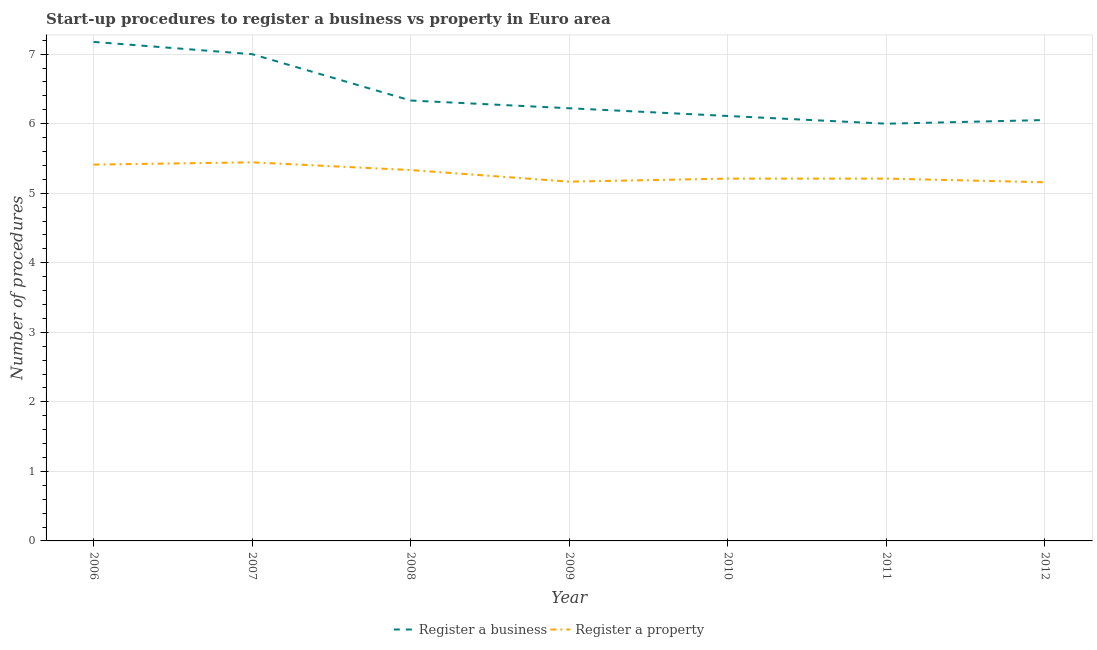Does the line corresponding to number of procedures to register a business intersect with the line corresponding to number of procedures to register a property?
Your response must be concise. No. What is the number of procedures to register a property in 2009?
Your answer should be very brief. 5.17. Across all years, what is the maximum number of procedures to register a business?
Offer a very short reply. 7.18. Across all years, what is the minimum number of procedures to register a property?
Provide a succinct answer. 5.16. What is the total number of procedures to register a property in the graph?
Offer a terse response. 36.94. What is the difference between the number of procedures to register a business in 2008 and that in 2010?
Ensure brevity in your answer.  0.22. What is the difference between the number of procedures to register a property in 2011 and the number of procedures to register a business in 2006?
Provide a short and direct response. -1.97. What is the average number of procedures to register a business per year?
Offer a terse response. 6.41. In the year 2009, what is the difference between the number of procedures to register a business and number of procedures to register a property?
Provide a succinct answer. 1.06. What is the ratio of the number of procedures to register a business in 2010 to that in 2012?
Offer a very short reply. 1.01. What is the difference between the highest and the second highest number of procedures to register a business?
Your answer should be very brief. 0.18. What is the difference between the highest and the lowest number of procedures to register a business?
Give a very brief answer. 1.18. Is the number of procedures to register a property strictly less than the number of procedures to register a business over the years?
Keep it short and to the point. Yes. How many years are there in the graph?
Make the answer very short. 7. Are the values on the major ticks of Y-axis written in scientific E-notation?
Keep it short and to the point. No. Where does the legend appear in the graph?
Make the answer very short. Bottom center. How many legend labels are there?
Provide a succinct answer. 2. How are the legend labels stacked?
Your answer should be compact. Horizontal. What is the title of the graph?
Provide a succinct answer. Start-up procedures to register a business vs property in Euro area. What is the label or title of the Y-axis?
Your response must be concise. Number of procedures. What is the Number of procedures of Register a business in 2006?
Provide a succinct answer. 7.18. What is the Number of procedures of Register a property in 2006?
Your answer should be compact. 5.41. What is the Number of procedures in Register a property in 2007?
Your response must be concise. 5.44. What is the Number of procedures of Register a business in 2008?
Offer a terse response. 6.33. What is the Number of procedures of Register a property in 2008?
Offer a very short reply. 5.33. What is the Number of procedures in Register a business in 2009?
Ensure brevity in your answer.  6.22. What is the Number of procedures of Register a property in 2009?
Your answer should be compact. 5.17. What is the Number of procedures of Register a business in 2010?
Offer a very short reply. 6.11. What is the Number of procedures of Register a property in 2010?
Provide a succinct answer. 5.21. What is the Number of procedures in Register a business in 2011?
Give a very brief answer. 6. What is the Number of procedures of Register a property in 2011?
Your answer should be compact. 5.21. What is the Number of procedures in Register a business in 2012?
Provide a succinct answer. 6.05. What is the Number of procedures of Register a property in 2012?
Provide a short and direct response. 5.16. Across all years, what is the maximum Number of procedures of Register a business?
Your answer should be very brief. 7.18. Across all years, what is the maximum Number of procedures of Register a property?
Offer a terse response. 5.44. Across all years, what is the minimum Number of procedures of Register a property?
Offer a very short reply. 5.16. What is the total Number of procedures in Register a business in the graph?
Your answer should be compact. 44.9. What is the total Number of procedures in Register a property in the graph?
Give a very brief answer. 36.94. What is the difference between the Number of procedures of Register a business in 2006 and that in 2007?
Ensure brevity in your answer.  0.18. What is the difference between the Number of procedures in Register a property in 2006 and that in 2007?
Your answer should be very brief. -0.03. What is the difference between the Number of procedures in Register a business in 2006 and that in 2008?
Ensure brevity in your answer.  0.84. What is the difference between the Number of procedures in Register a property in 2006 and that in 2008?
Your answer should be very brief. 0.08. What is the difference between the Number of procedures in Register a business in 2006 and that in 2009?
Provide a succinct answer. 0.95. What is the difference between the Number of procedures in Register a property in 2006 and that in 2009?
Provide a short and direct response. 0.25. What is the difference between the Number of procedures in Register a business in 2006 and that in 2010?
Give a very brief answer. 1.07. What is the difference between the Number of procedures in Register a property in 2006 and that in 2010?
Ensure brevity in your answer.  0.2. What is the difference between the Number of procedures in Register a business in 2006 and that in 2011?
Ensure brevity in your answer.  1.18. What is the difference between the Number of procedures in Register a property in 2006 and that in 2011?
Provide a succinct answer. 0.2. What is the difference between the Number of procedures in Register a business in 2006 and that in 2012?
Your answer should be compact. 1.12. What is the difference between the Number of procedures of Register a property in 2006 and that in 2012?
Ensure brevity in your answer.  0.25. What is the difference between the Number of procedures in Register a business in 2007 and that in 2009?
Make the answer very short. 0.78. What is the difference between the Number of procedures in Register a property in 2007 and that in 2009?
Your answer should be compact. 0.28. What is the difference between the Number of procedures of Register a property in 2007 and that in 2010?
Ensure brevity in your answer.  0.23. What is the difference between the Number of procedures in Register a property in 2007 and that in 2011?
Provide a succinct answer. 0.23. What is the difference between the Number of procedures of Register a business in 2007 and that in 2012?
Make the answer very short. 0.95. What is the difference between the Number of procedures of Register a property in 2007 and that in 2012?
Ensure brevity in your answer.  0.29. What is the difference between the Number of procedures in Register a business in 2008 and that in 2009?
Keep it short and to the point. 0.11. What is the difference between the Number of procedures in Register a property in 2008 and that in 2009?
Your answer should be very brief. 0.17. What is the difference between the Number of procedures in Register a business in 2008 and that in 2010?
Your answer should be compact. 0.22. What is the difference between the Number of procedures of Register a property in 2008 and that in 2010?
Your answer should be very brief. 0.12. What is the difference between the Number of procedures in Register a business in 2008 and that in 2011?
Give a very brief answer. 0.33. What is the difference between the Number of procedures in Register a property in 2008 and that in 2011?
Make the answer very short. 0.12. What is the difference between the Number of procedures of Register a business in 2008 and that in 2012?
Your answer should be very brief. 0.28. What is the difference between the Number of procedures of Register a property in 2008 and that in 2012?
Your answer should be very brief. 0.18. What is the difference between the Number of procedures in Register a business in 2009 and that in 2010?
Your response must be concise. 0.11. What is the difference between the Number of procedures in Register a property in 2009 and that in 2010?
Ensure brevity in your answer.  -0.04. What is the difference between the Number of procedures of Register a business in 2009 and that in 2011?
Make the answer very short. 0.22. What is the difference between the Number of procedures of Register a property in 2009 and that in 2011?
Your answer should be compact. -0.04. What is the difference between the Number of procedures in Register a business in 2009 and that in 2012?
Keep it short and to the point. 0.17. What is the difference between the Number of procedures of Register a property in 2009 and that in 2012?
Make the answer very short. 0.01. What is the difference between the Number of procedures in Register a business in 2010 and that in 2011?
Ensure brevity in your answer.  0.11. What is the difference between the Number of procedures in Register a business in 2010 and that in 2012?
Keep it short and to the point. 0.06. What is the difference between the Number of procedures in Register a property in 2010 and that in 2012?
Your response must be concise. 0.05. What is the difference between the Number of procedures of Register a business in 2011 and that in 2012?
Your response must be concise. -0.05. What is the difference between the Number of procedures in Register a property in 2011 and that in 2012?
Provide a succinct answer. 0.05. What is the difference between the Number of procedures of Register a business in 2006 and the Number of procedures of Register a property in 2007?
Provide a short and direct response. 1.73. What is the difference between the Number of procedures of Register a business in 2006 and the Number of procedures of Register a property in 2008?
Your answer should be very brief. 1.84. What is the difference between the Number of procedures of Register a business in 2006 and the Number of procedures of Register a property in 2009?
Ensure brevity in your answer.  2.01. What is the difference between the Number of procedures in Register a business in 2006 and the Number of procedures in Register a property in 2010?
Offer a very short reply. 1.97. What is the difference between the Number of procedures in Register a business in 2006 and the Number of procedures in Register a property in 2011?
Make the answer very short. 1.97. What is the difference between the Number of procedures of Register a business in 2006 and the Number of procedures of Register a property in 2012?
Provide a succinct answer. 2.02. What is the difference between the Number of procedures of Register a business in 2007 and the Number of procedures of Register a property in 2008?
Offer a very short reply. 1.67. What is the difference between the Number of procedures in Register a business in 2007 and the Number of procedures in Register a property in 2009?
Make the answer very short. 1.83. What is the difference between the Number of procedures in Register a business in 2007 and the Number of procedures in Register a property in 2010?
Keep it short and to the point. 1.79. What is the difference between the Number of procedures of Register a business in 2007 and the Number of procedures of Register a property in 2011?
Your answer should be very brief. 1.79. What is the difference between the Number of procedures of Register a business in 2007 and the Number of procedures of Register a property in 2012?
Keep it short and to the point. 1.84. What is the difference between the Number of procedures in Register a business in 2008 and the Number of procedures in Register a property in 2010?
Your answer should be compact. 1.12. What is the difference between the Number of procedures of Register a business in 2008 and the Number of procedures of Register a property in 2011?
Make the answer very short. 1.12. What is the difference between the Number of procedures in Register a business in 2008 and the Number of procedures in Register a property in 2012?
Give a very brief answer. 1.18. What is the difference between the Number of procedures in Register a business in 2009 and the Number of procedures in Register a property in 2010?
Your answer should be compact. 1.01. What is the difference between the Number of procedures in Register a business in 2009 and the Number of procedures in Register a property in 2011?
Your answer should be very brief. 1.01. What is the difference between the Number of procedures of Register a business in 2009 and the Number of procedures of Register a property in 2012?
Offer a very short reply. 1.06. What is the difference between the Number of procedures in Register a business in 2010 and the Number of procedures in Register a property in 2011?
Offer a terse response. 0.9. What is the difference between the Number of procedures of Register a business in 2010 and the Number of procedures of Register a property in 2012?
Provide a succinct answer. 0.95. What is the difference between the Number of procedures in Register a business in 2011 and the Number of procedures in Register a property in 2012?
Give a very brief answer. 0.84. What is the average Number of procedures of Register a business per year?
Your answer should be compact. 6.41. What is the average Number of procedures of Register a property per year?
Offer a very short reply. 5.28. In the year 2006, what is the difference between the Number of procedures in Register a business and Number of procedures in Register a property?
Offer a terse response. 1.76. In the year 2007, what is the difference between the Number of procedures in Register a business and Number of procedures in Register a property?
Make the answer very short. 1.56. In the year 2009, what is the difference between the Number of procedures of Register a business and Number of procedures of Register a property?
Provide a short and direct response. 1.06. In the year 2010, what is the difference between the Number of procedures of Register a business and Number of procedures of Register a property?
Ensure brevity in your answer.  0.9. In the year 2011, what is the difference between the Number of procedures of Register a business and Number of procedures of Register a property?
Provide a short and direct response. 0.79. In the year 2012, what is the difference between the Number of procedures in Register a business and Number of procedures in Register a property?
Provide a short and direct response. 0.89. What is the ratio of the Number of procedures in Register a business in 2006 to that in 2007?
Your response must be concise. 1.03. What is the ratio of the Number of procedures in Register a business in 2006 to that in 2008?
Your response must be concise. 1.13. What is the ratio of the Number of procedures of Register a property in 2006 to that in 2008?
Ensure brevity in your answer.  1.01. What is the ratio of the Number of procedures in Register a business in 2006 to that in 2009?
Your answer should be compact. 1.15. What is the ratio of the Number of procedures in Register a property in 2006 to that in 2009?
Keep it short and to the point. 1.05. What is the ratio of the Number of procedures of Register a business in 2006 to that in 2010?
Offer a very short reply. 1.17. What is the ratio of the Number of procedures in Register a property in 2006 to that in 2010?
Make the answer very short. 1.04. What is the ratio of the Number of procedures in Register a business in 2006 to that in 2011?
Your answer should be very brief. 1.2. What is the ratio of the Number of procedures of Register a property in 2006 to that in 2011?
Offer a terse response. 1.04. What is the ratio of the Number of procedures in Register a business in 2006 to that in 2012?
Provide a short and direct response. 1.19. What is the ratio of the Number of procedures of Register a property in 2006 to that in 2012?
Offer a very short reply. 1.05. What is the ratio of the Number of procedures of Register a business in 2007 to that in 2008?
Your answer should be very brief. 1.11. What is the ratio of the Number of procedures of Register a property in 2007 to that in 2008?
Provide a succinct answer. 1.02. What is the ratio of the Number of procedures of Register a property in 2007 to that in 2009?
Keep it short and to the point. 1.05. What is the ratio of the Number of procedures in Register a business in 2007 to that in 2010?
Give a very brief answer. 1.15. What is the ratio of the Number of procedures of Register a property in 2007 to that in 2010?
Your response must be concise. 1.04. What is the ratio of the Number of procedures of Register a business in 2007 to that in 2011?
Your response must be concise. 1.17. What is the ratio of the Number of procedures in Register a property in 2007 to that in 2011?
Make the answer very short. 1.04. What is the ratio of the Number of procedures in Register a business in 2007 to that in 2012?
Your answer should be very brief. 1.16. What is the ratio of the Number of procedures in Register a property in 2007 to that in 2012?
Offer a terse response. 1.06. What is the ratio of the Number of procedures in Register a business in 2008 to that in 2009?
Your answer should be very brief. 1.02. What is the ratio of the Number of procedures of Register a property in 2008 to that in 2009?
Your answer should be very brief. 1.03. What is the ratio of the Number of procedures in Register a business in 2008 to that in 2010?
Your answer should be compact. 1.04. What is the ratio of the Number of procedures in Register a property in 2008 to that in 2010?
Give a very brief answer. 1.02. What is the ratio of the Number of procedures in Register a business in 2008 to that in 2011?
Your answer should be very brief. 1.06. What is the ratio of the Number of procedures of Register a property in 2008 to that in 2011?
Make the answer very short. 1.02. What is the ratio of the Number of procedures in Register a business in 2008 to that in 2012?
Your response must be concise. 1.05. What is the ratio of the Number of procedures of Register a property in 2008 to that in 2012?
Offer a terse response. 1.03. What is the ratio of the Number of procedures in Register a business in 2009 to that in 2010?
Your response must be concise. 1.02. What is the ratio of the Number of procedures of Register a property in 2009 to that in 2011?
Your response must be concise. 0.99. What is the ratio of the Number of procedures in Register a business in 2009 to that in 2012?
Keep it short and to the point. 1.03. What is the ratio of the Number of procedures in Register a property in 2009 to that in 2012?
Make the answer very short. 1. What is the ratio of the Number of procedures in Register a business in 2010 to that in 2011?
Make the answer very short. 1.02. What is the ratio of the Number of procedures in Register a business in 2010 to that in 2012?
Your response must be concise. 1.01. What is the ratio of the Number of procedures of Register a property in 2010 to that in 2012?
Offer a terse response. 1.01. What is the ratio of the Number of procedures in Register a business in 2011 to that in 2012?
Give a very brief answer. 0.99. What is the ratio of the Number of procedures in Register a property in 2011 to that in 2012?
Ensure brevity in your answer.  1.01. What is the difference between the highest and the second highest Number of procedures of Register a business?
Your response must be concise. 0.18. What is the difference between the highest and the second highest Number of procedures of Register a property?
Give a very brief answer. 0.03. What is the difference between the highest and the lowest Number of procedures of Register a business?
Ensure brevity in your answer.  1.18. What is the difference between the highest and the lowest Number of procedures of Register a property?
Provide a succinct answer. 0.29. 